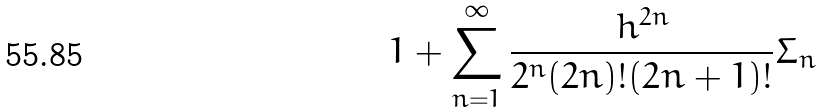<formula> <loc_0><loc_0><loc_500><loc_500>1 + \sum _ { n = 1 } ^ { \infty } \frac { h ^ { 2 n } } { 2 ^ { n } ( 2 n ) ! ( 2 n + 1 ) ! } \Sigma _ { n }</formula> 